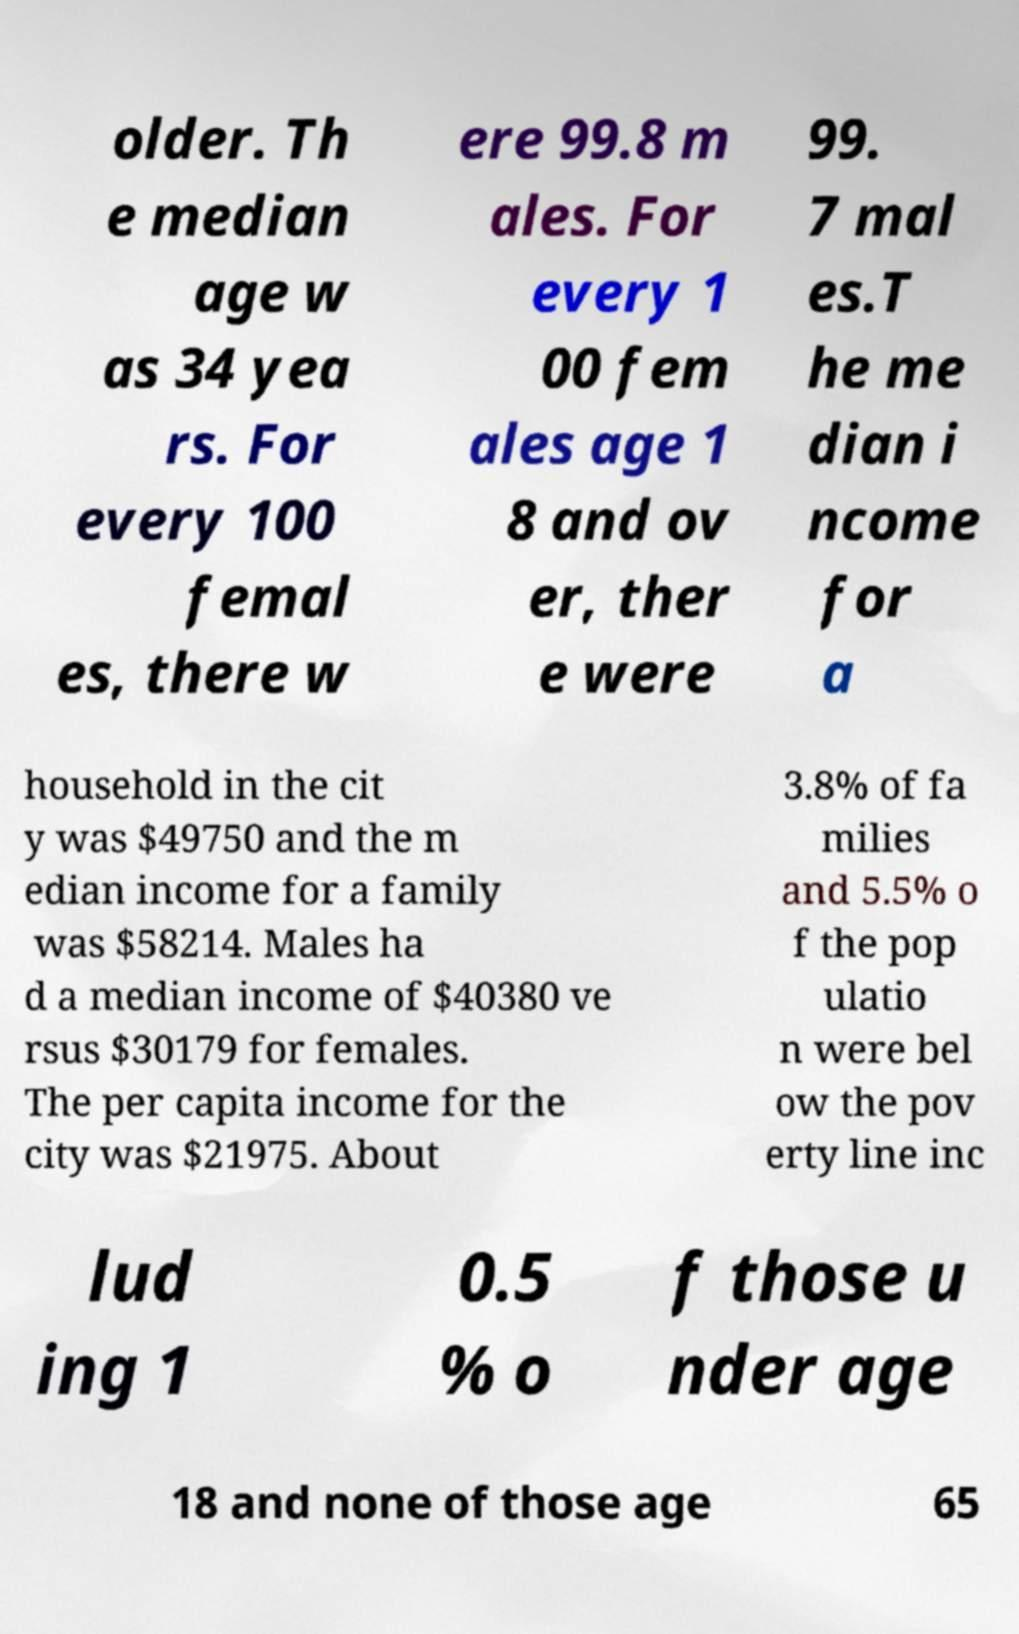Can you accurately transcribe the text from the provided image for me? older. Th e median age w as 34 yea rs. For every 100 femal es, there w ere 99.8 m ales. For every 1 00 fem ales age 1 8 and ov er, ther e were 99. 7 mal es.T he me dian i ncome for a household in the cit y was $49750 and the m edian income for a family was $58214. Males ha d a median income of $40380 ve rsus $30179 for females. The per capita income for the city was $21975. About 3.8% of fa milies and 5.5% o f the pop ulatio n were bel ow the pov erty line inc lud ing 1 0.5 % o f those u nder age 18 and none of those age 65 